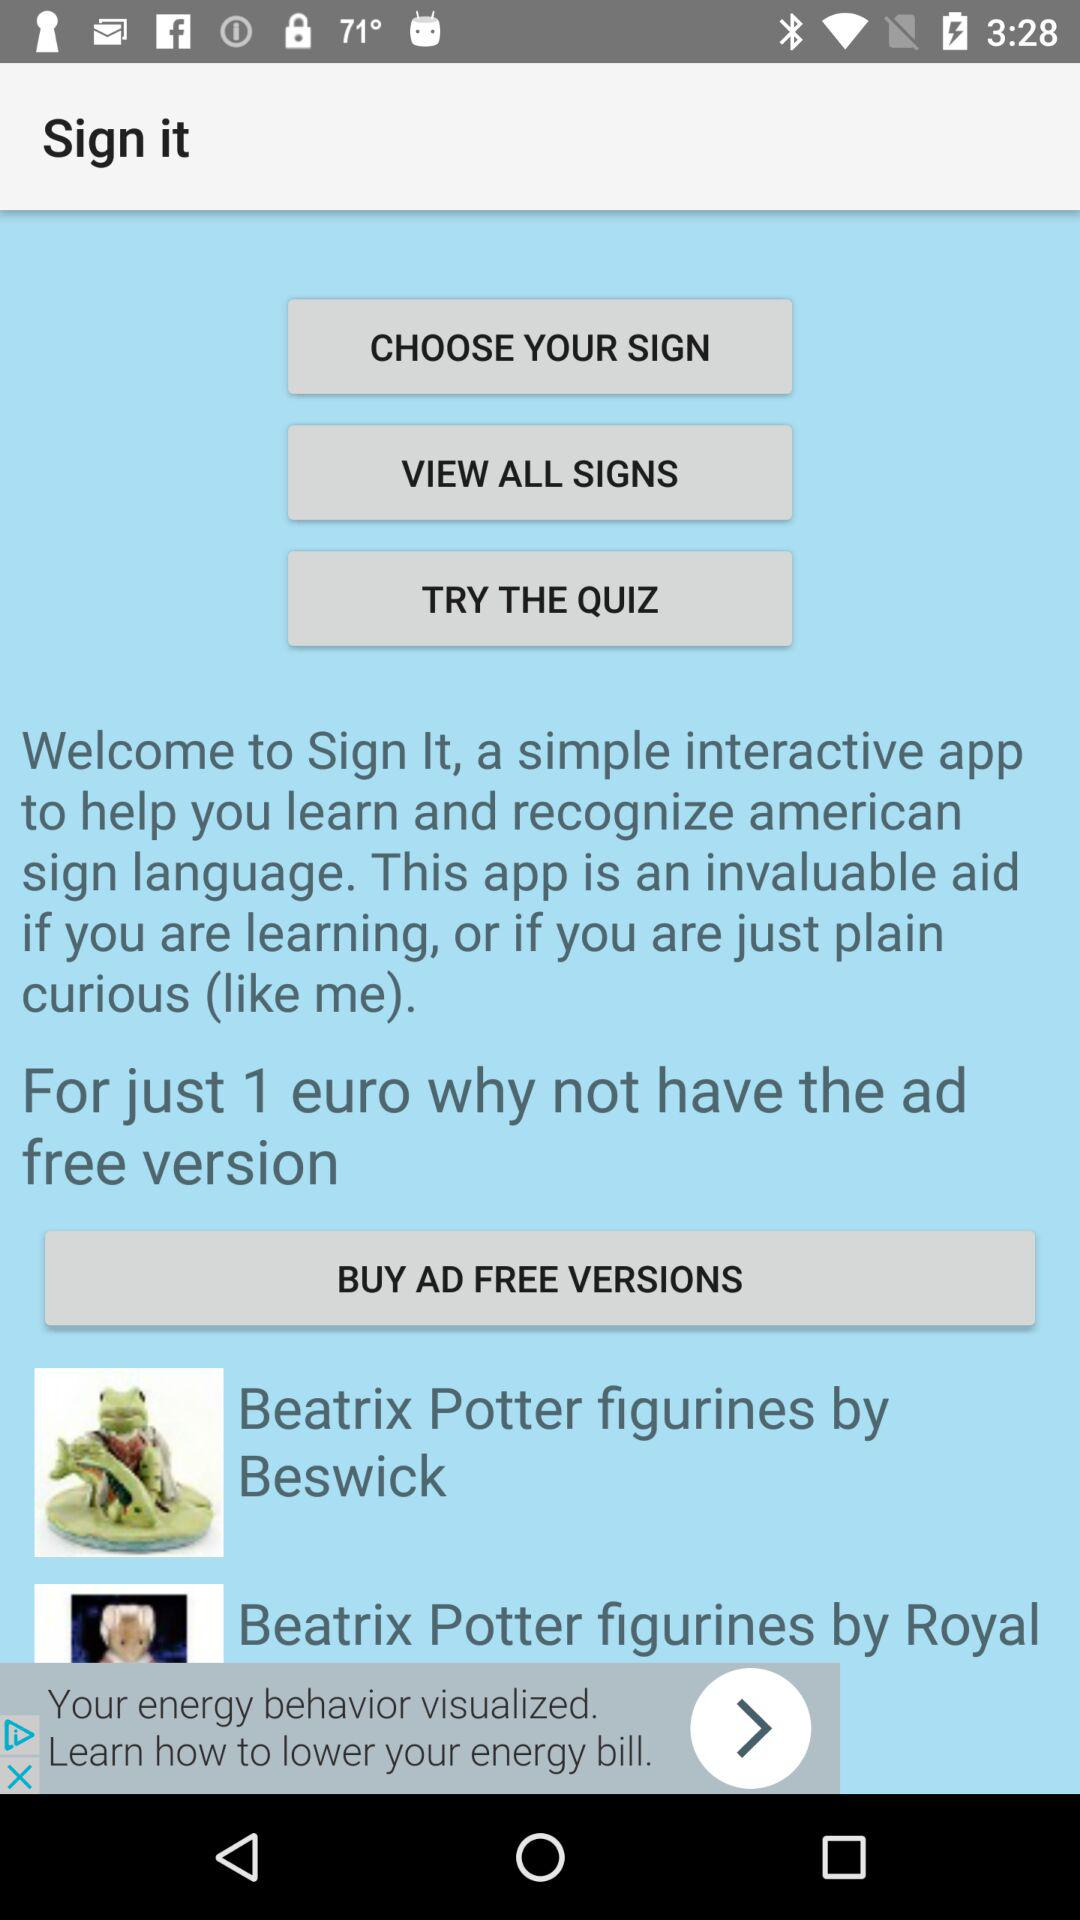How many Beatrix Potter figurines are featured in the app?
Answer the question using a single word or phrase. 2 